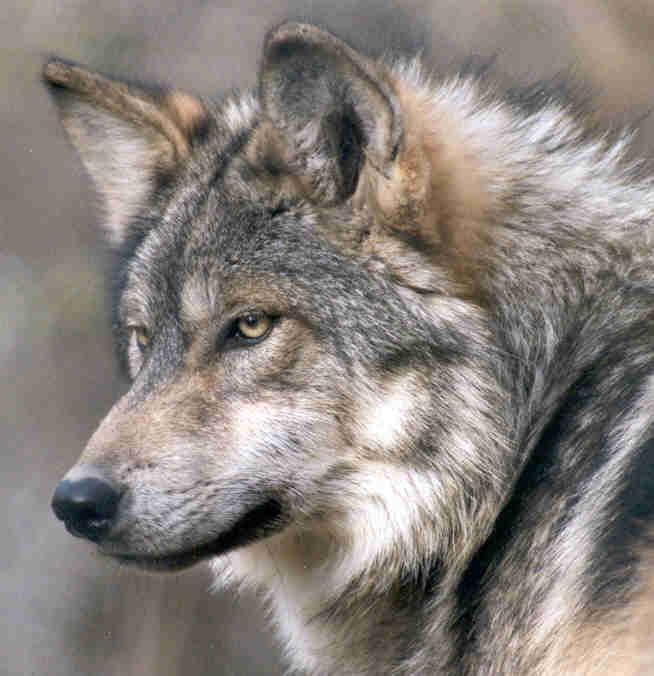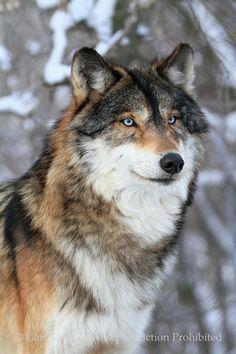The first image is the image on the left, the second image is the image on the right. Given the left and right images, does the statement "in both photos the wolf is facing the same direction" hold true? Answer yes or no. No. The first image is the image on the left, the second image is the image on the right. For the images shown, is this caption "wolves are facing oposite directions in the image pair" true? Answer yes or no. Yes. 